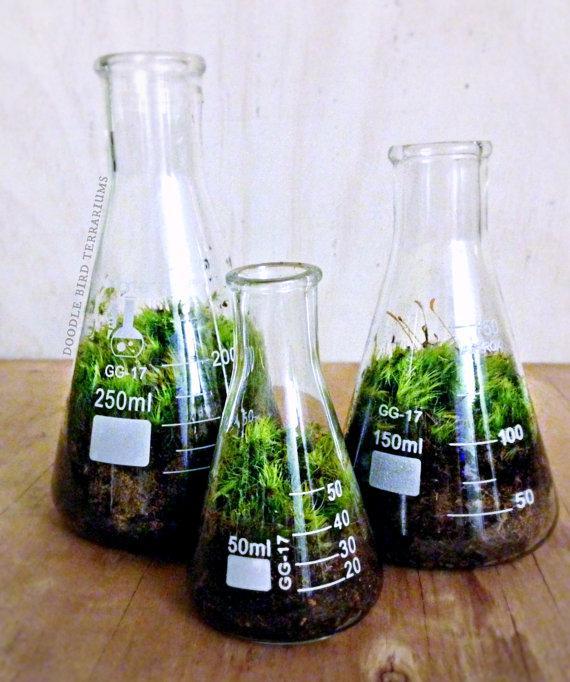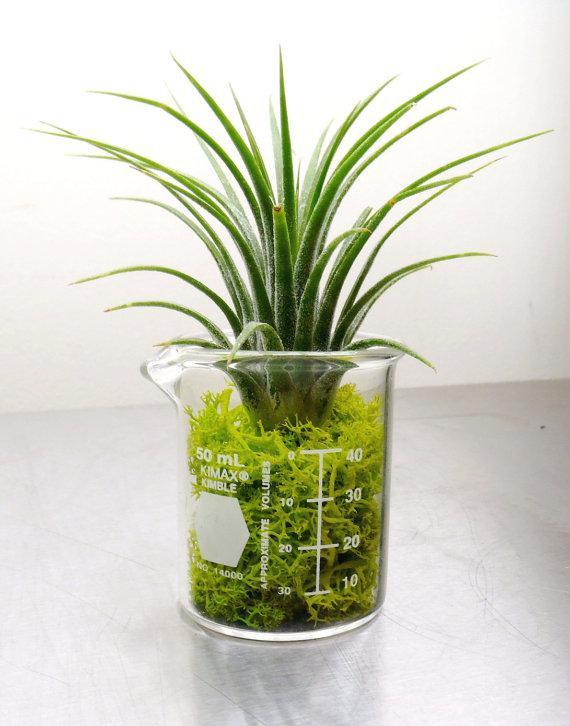The first image is the image on the left, the second image is the image on the right. For the images displayed, is the sentence "There are exactly three plants in the left image." factually correct? Answer yes or no. Yes. The first image is the image on the left, the second image is the image on the right. For the images shown, is this caption "There is a total of 6 beakers and tubes with single plants or stems in it." true? Answer yes or no. No. 